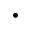Convert formula to latex. <formula><loc_0><loc_0><loc_500><loc_500>\cdot</formula> 